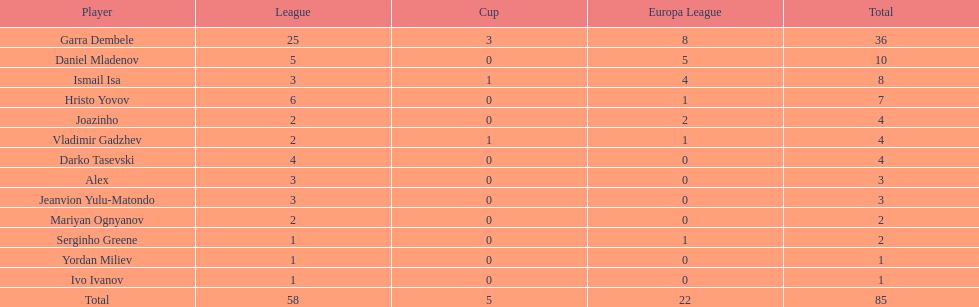Which aggregate is higher, the europa league total or the league total? League. 